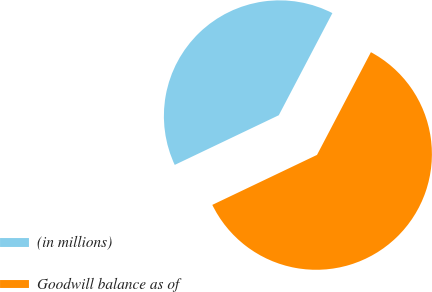<chart> <loc_0><loc_0><loc_500><loc_500><pie_chart><fcel>(in millions)<fcel>Goodwill balance as of<nl><fcel>39.78%<fcel>60.22%<nl></chart> 